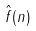<formula> <loc_0><loc_0><loc_500><loc_500>\hat { f } ( n )</formula> 